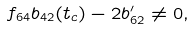<formula> <loc_0><loc_0><loc_500><loc_500>f _ { 6 4 } b _ { 4 2 } ( t _ { c } ) - 2 b ^ { \prime } _ { 6 2 } \neq 0 ,</formula> 